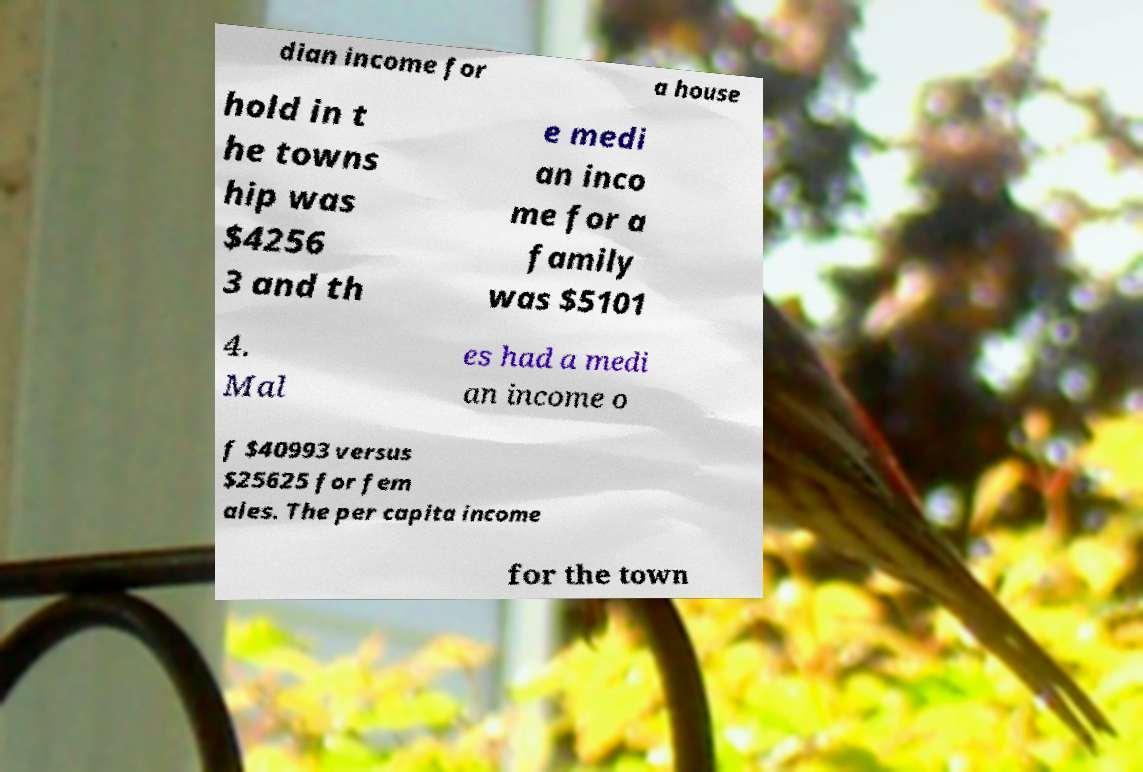Can you accurately transcribe the text from the provided image for me? dian income for a house hold in t he towns hip was $4256 3 and th e medi an inco me for a family was $5101 4. Mal es had a medi an income o f $40993 versus $25625 for fem ales. The per capita income for the town 